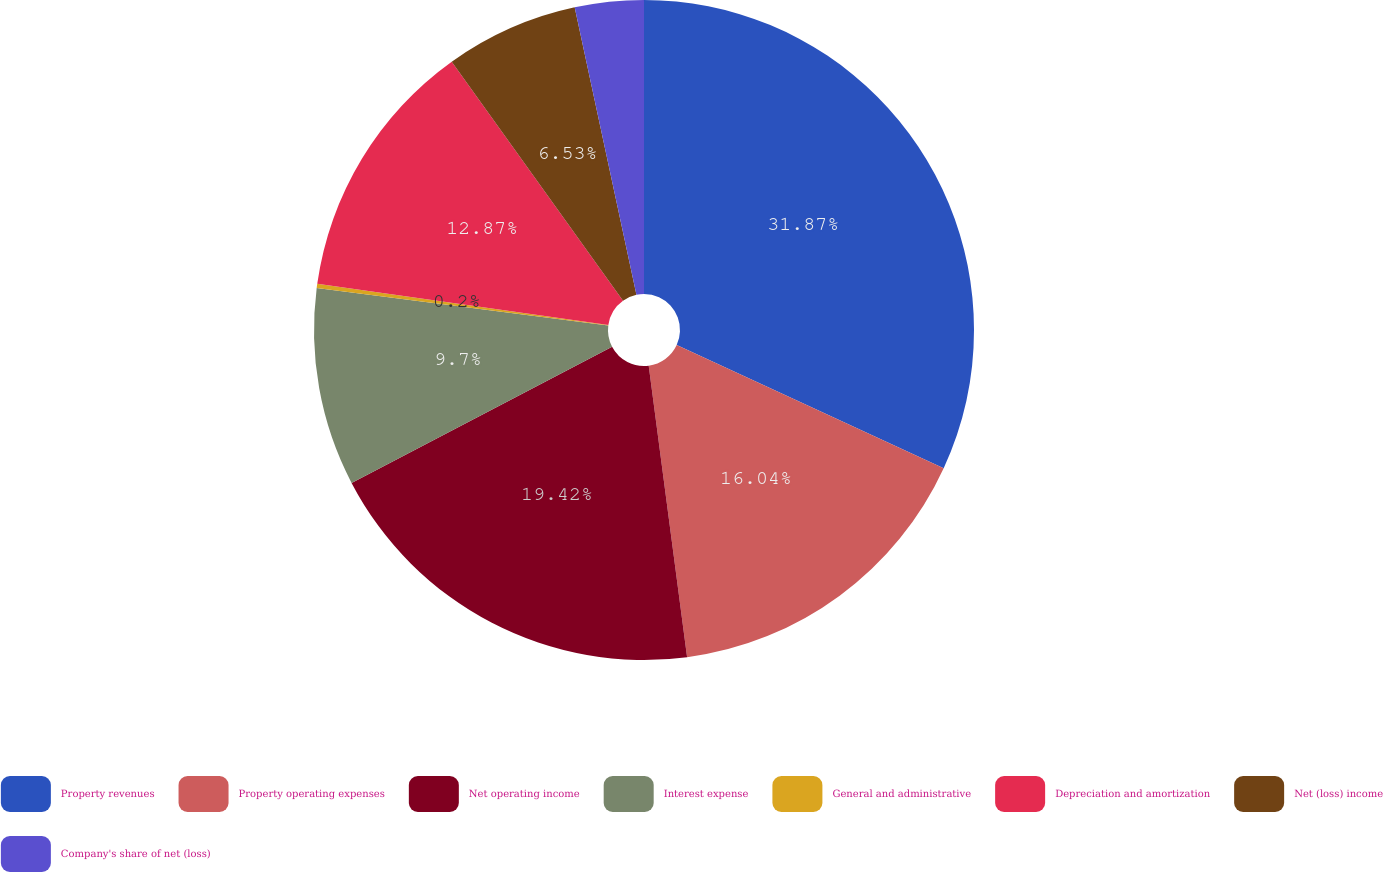Convert chart. <chart><loc_0><loc_0><loc_500><loc_500><pie_chart><fcel>Property revenues<fcel>Property operating expenses<fcel>Net operating income<fcel>Interest expense<fcel>General and administrative<fcel>Depreciation and amortization<fcel>Net (loss) income<fcel>Company's share of net (loss)<nl><fcel>31.88%<fcel>16.04%<fcel>19.42%<fcel>9.7%<fcel>0.2%<fcel>12.87%<fcel>6.53%<fcel>3.37%<nl></chart> 